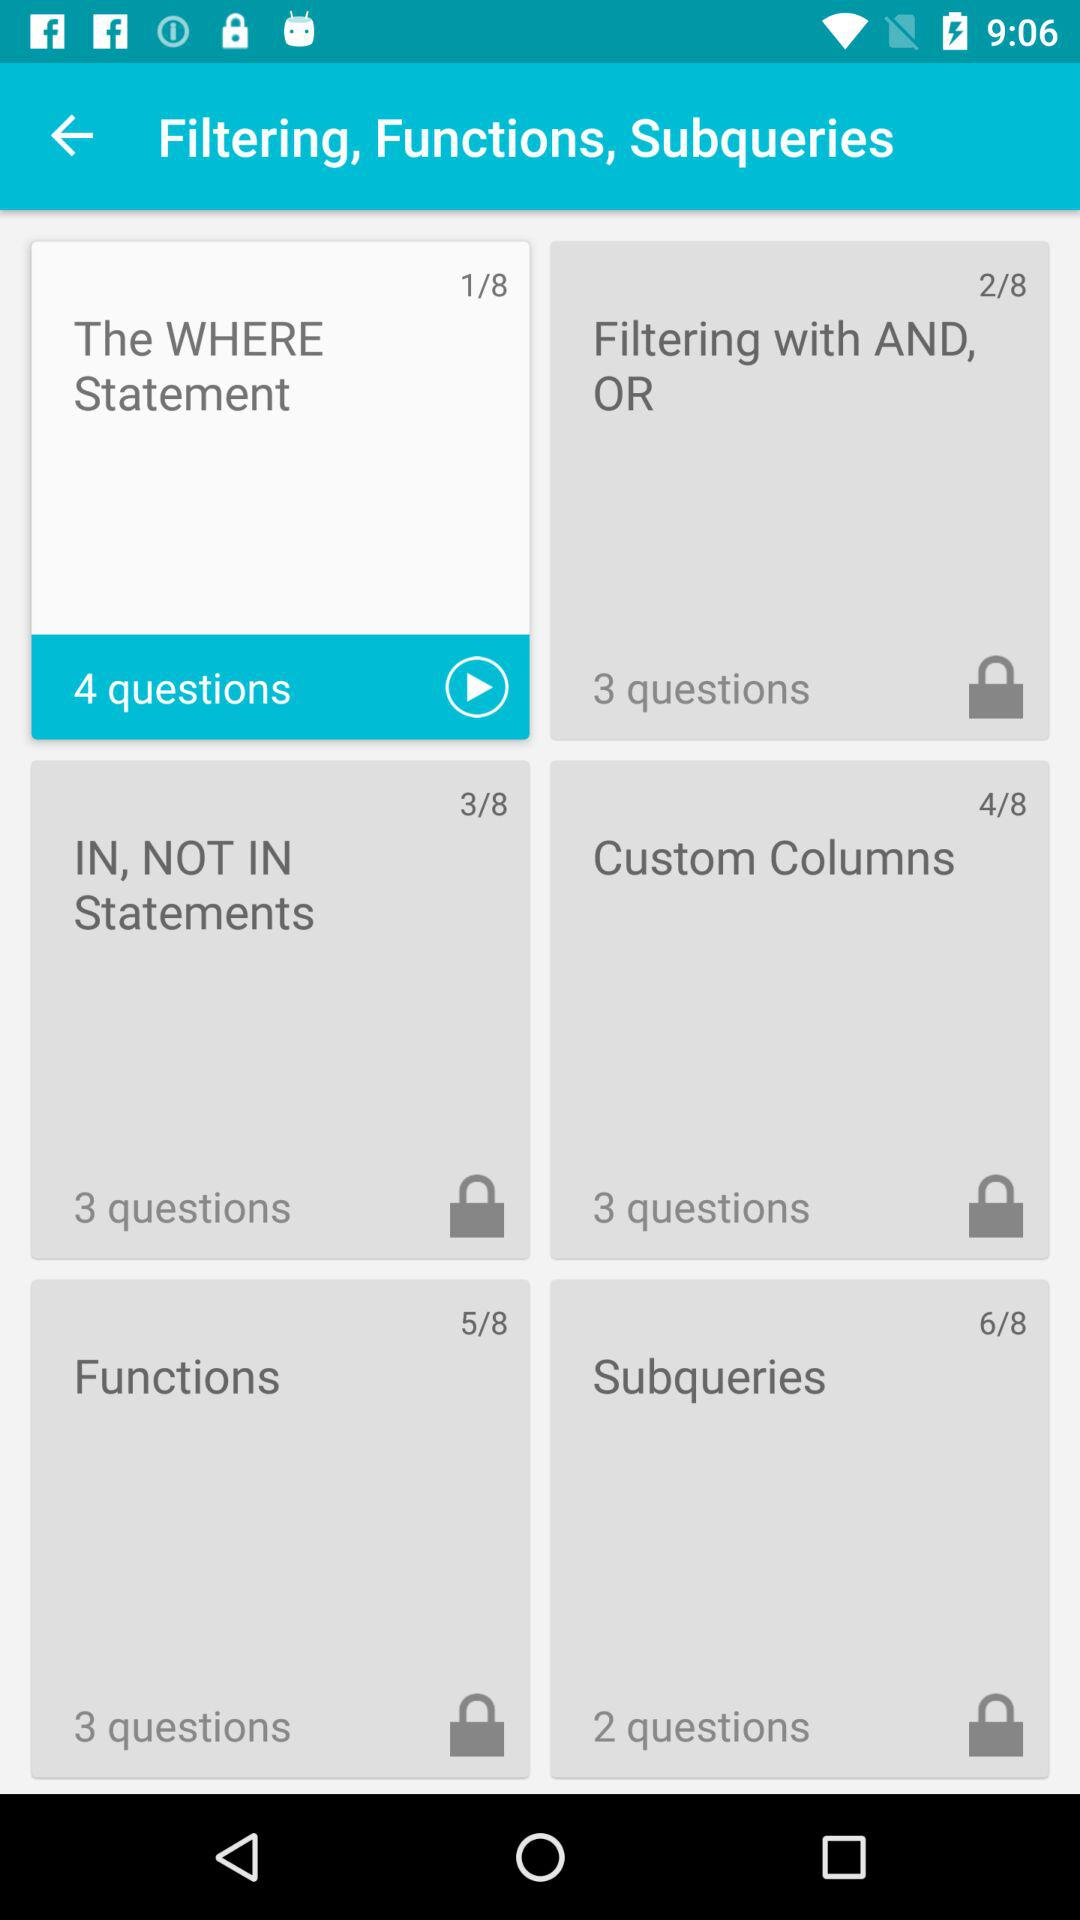On which slide am I in the "Functions" slide? In the "Functions" slide, you are on slide 5. 